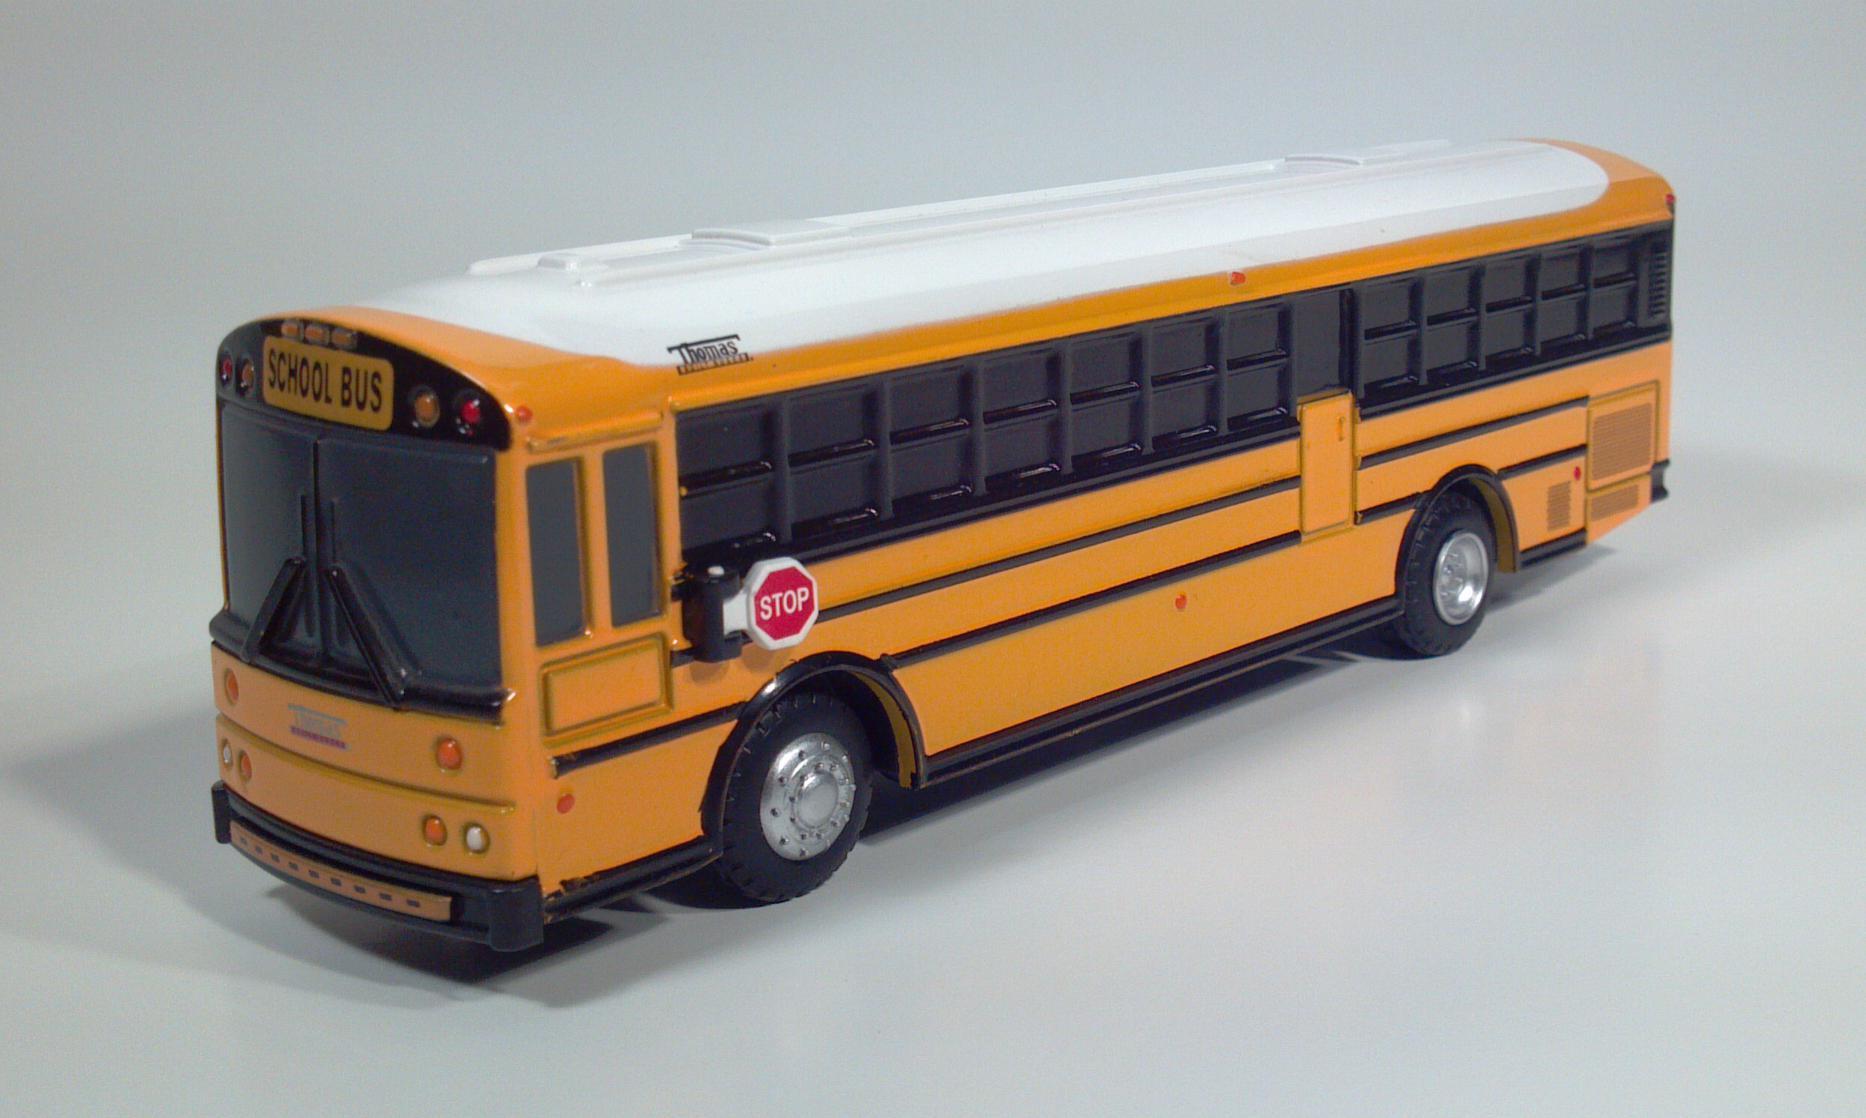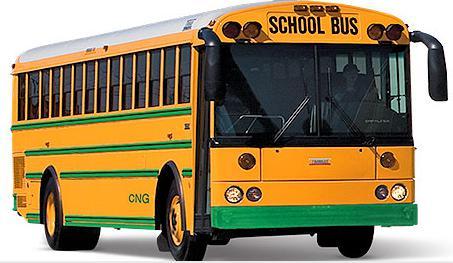The first image is the image on the left, the second image is the image on the right. For the images shown, is this caption "Each image contains at least one flat-fronted yellow bus, and the bus in the right image is angled rightward." true? Answer yes or no. Yes. The first image is the image on the left, the second image is the image on the right. Given the left and right images, does the statement "There is one bus pointing left in the left image." hold true? Answer yes or no. Yes. 